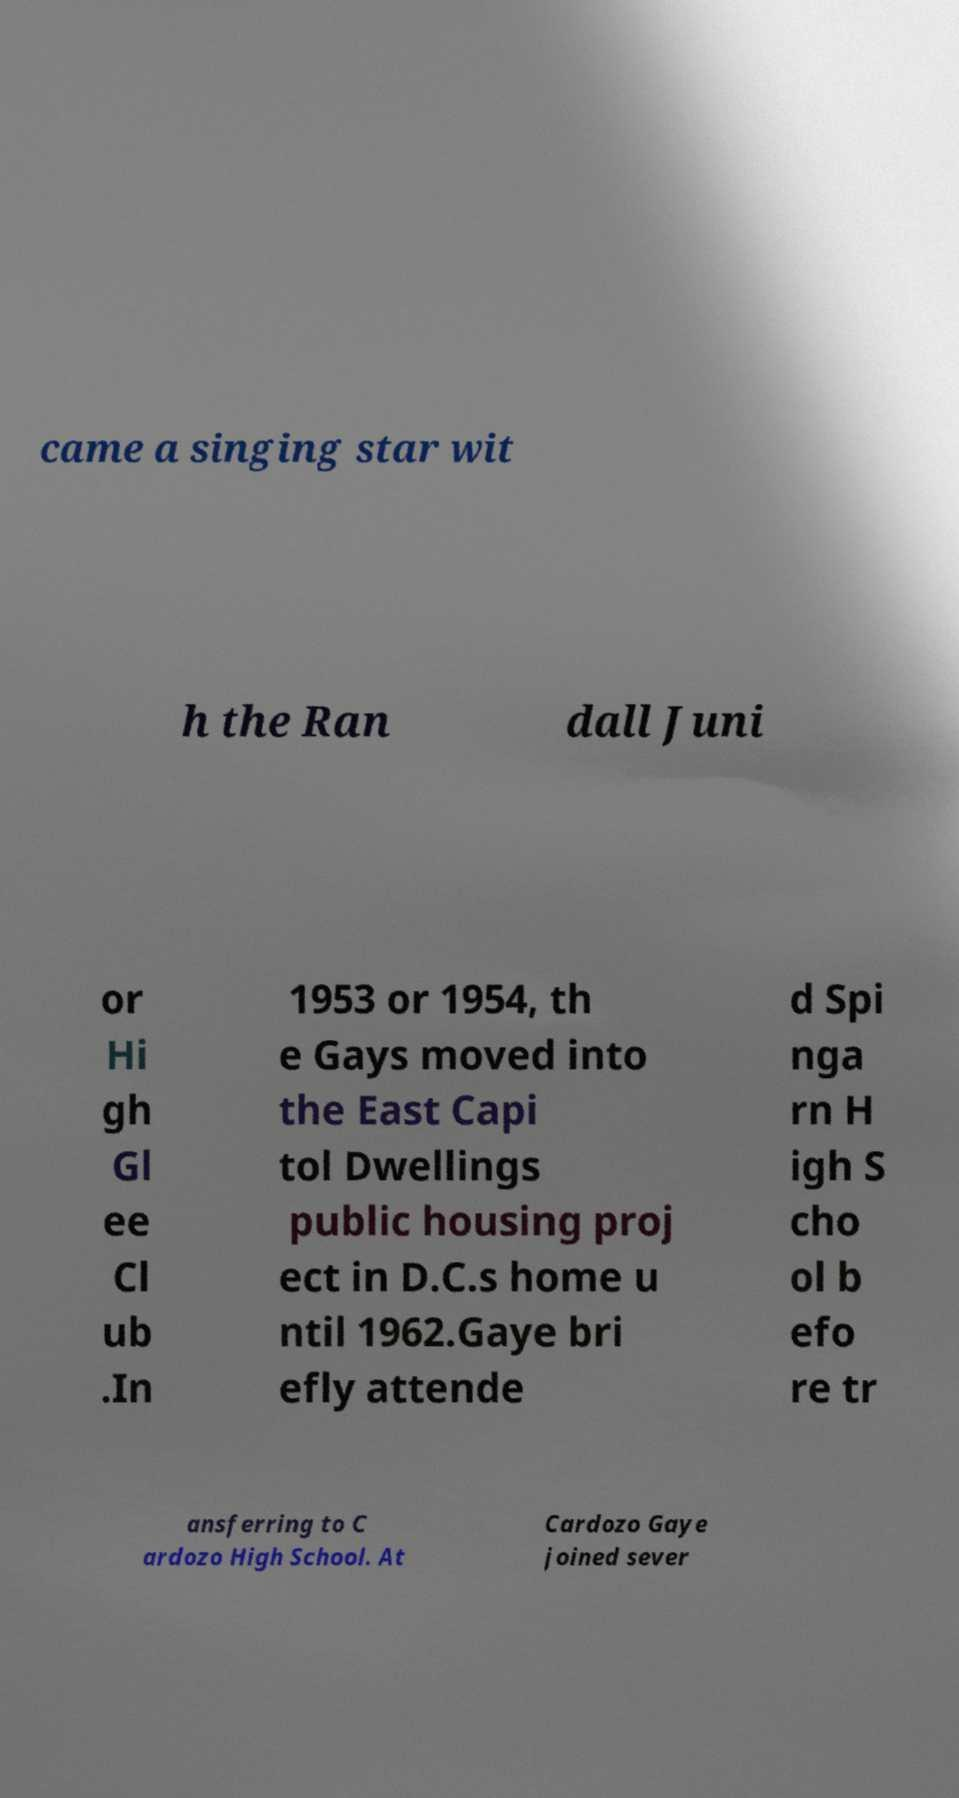Please read and relay the text visible in this image. What does it say? came a singing star wit h the Ran dall Juni or Hi gh Gl ee Cl ub .In 1953 or 1954, th e Gays moved into the East Capi tol Dwellings public housing proj ect in D.C.s home u ntil 1962.Gaye bri efly attende d Spi nga rn H igh S cho ol b efo re tr ansferring to C ardozo High School. At Cardozo Gaye joined sever 